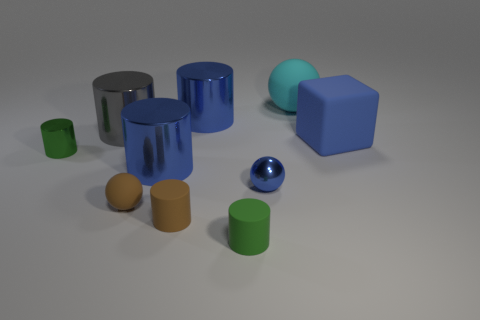Subtract all gray cylinders. How many cylinders are left? 5 Subtract all brown cylinders. How many cylinders are left? 5 Subtract all green cylinders. Subtract all green blocks. How many cylinders are left? 4 Subtract all cubes. How many objects are left? 9 Add 6 blue cubes. How many blue cubes exist? 7 Subtract 0 brown cubes. How many objects are left? 10 Subtract all brown matte objects. Subtract all small green metal objects. How many objects are left? 7 Add 1 small matte cylinders. How many small matte cylinders are left? 3 